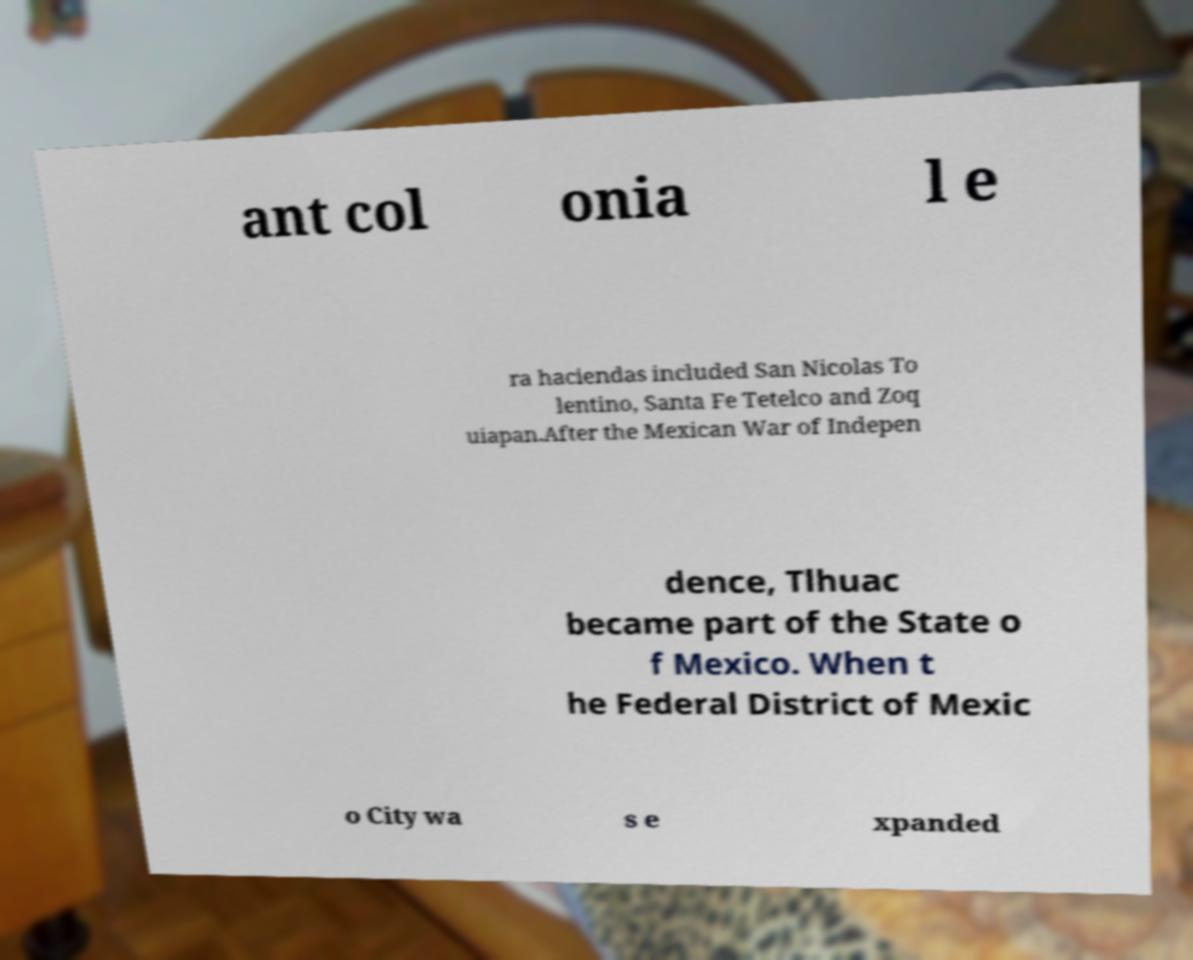Please read and relay the text visible in this image. What does it say? ant col onia l e ra haciendas included San Nicolas To lentino, Santa Fe Tetelco and Zoq uiapan.After the Mexican War of Indepen dence, Tlhuac became part of the State o f Mexico. When t he Federal District of Mexic o City wa s e xpanded 